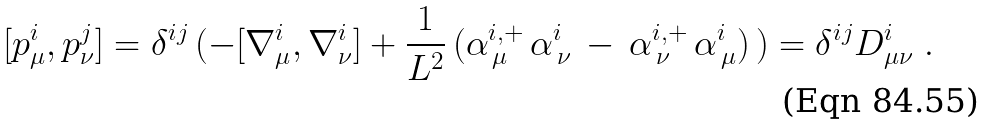<formula> <loc_0><loc_0><loc_500><loc_500>[ p ^ { i } _ { \mu } , p ^ { j } _ { \nu } ] = \delta ^ { i j } \, ( - [ \nabla ^ { i } _ { \mu } , \nabla ^ { i } _ { \nu } ] + \frac { 1 } { L ^ { 2 } } \, ( \alpha _ { \, \mu } ^ { i , + } \, \alpha _ { \, \nu } ^ { i } \, - \, \alpha _ { \, \nu } ^ { i , + } \, \alpha _ { \, \mu } ^ { i } ) \, ) = \delta ^ { i j } D _ { \mu \nu } ^ { i } \ .</formula> 